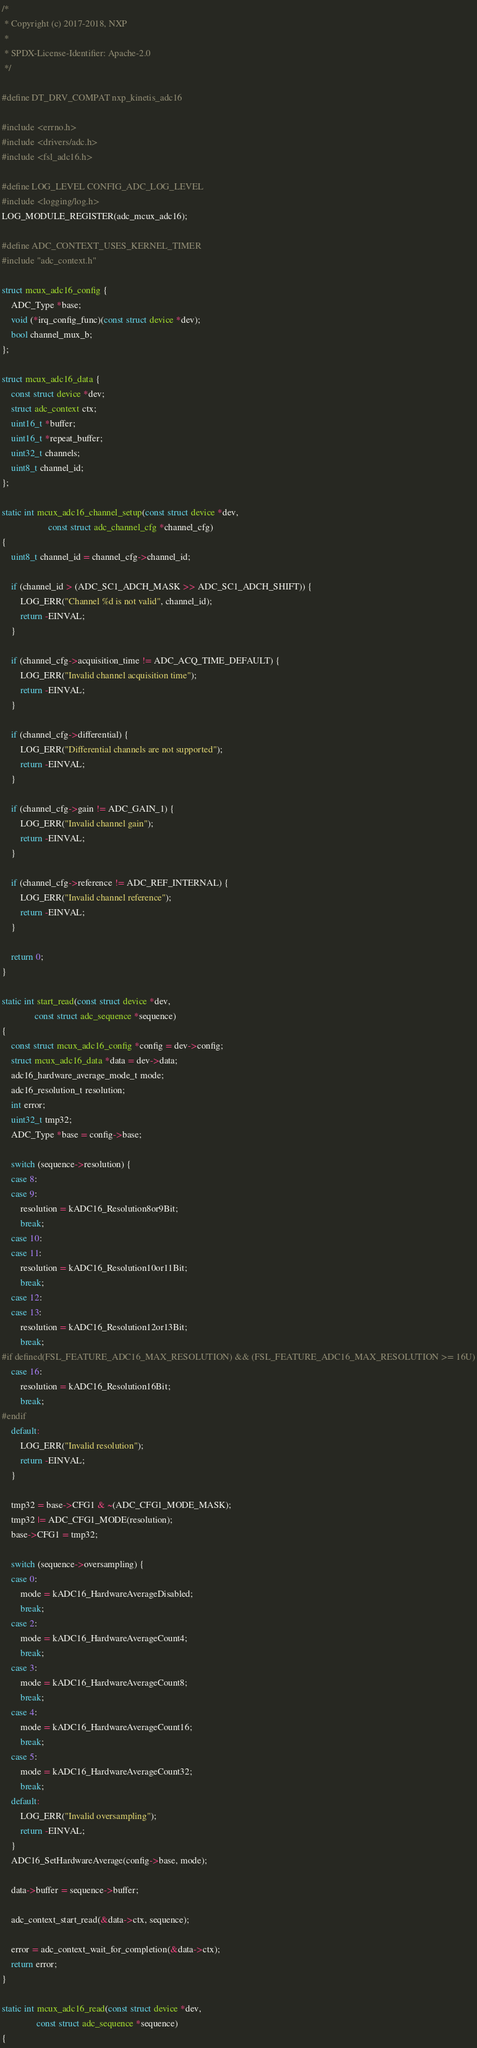Convert code to text. <code><loc_0><loc_0><loc_500><loc_500><_C_>/*
 * Copyright (c) 2017-2018, NXP
 *
 * SPDX-License-Identifier: Apache-2.0
 */

#define DT_DRV_COMPAT nxp_kinetis_adc16

#include <errno.h>
#include <drivers/adc.h>
#include <fsl_adc16.h>

#define LOG_LEVEL CONFIG_ADC_LOG_LEVEL
#include <logging/log.h>
LOG_MODULE_REGISTER(adc_mcux_adc16);

#define ADC_CONTEXT_USES_KERNEL_TIMER
#include "adc_context.h"

struct mcux_adc16_config {
	ADC_Type *base;
	void (*irq_config_func)(const struct device *dev);
	bool channel_mux_b;
};

struct mcux_adc16_data {
	const struct device *dev;
	struct adc_context ctx;
	uint16_t *buffer;
	uint16_t *repeat_buffer;
	uint32_t channels;
	uint8_t channel_id;
};

static int mcux_adc16_channel_setup(const struct device *dev,
				    const struct adc_channel_cfg *channel_cfg)
{
	uint8_t channel_id = channel_cfg->channel_id;

	if (channel_id > (ADC_SC1_ADCH_MASK >> ADC_SC1_ADCH_SHIFT)) {
		LOG_ERR("Channel %d is not valid", channel_id);
		return -EINVAL;
	}

	if (channel_cfg->acquisition_time != ADC_ACQ_TIME_DEFAULT) {
		LOG_ERR("Invalid channel acquisition time");
		return -EINVAL;
	}

	if (channel_cfg->differential) {
		LOG_ERR("Differential channels are not supported");
		return -EINVAL;
	}

	if (channel_cfg->gain != ADC_GAIN_1) {
		LOG_ERR("Invalid channel gain");
		return -EINVAL;
	}

	if (channel_cfg->reference != ADC_REF_INTERNAL) {
		LOG_ERR("Invalid channel reference");
		return -EINVAL;
	}

	return 0;
}

static int start_read(const struct device *dev,
		      const struct adc_sequence *sequence)
{
	const struct mcux_adc16_config *config = dev->config;
	struct mcux_adc16_data *data = dev->data;
	adc16_hardware_average_mode_t mode;
	adc16_resolution_t resolution;
	int error;
	uint32_t tmp32;
	ADC_Type *base = config->base;

	switch (sequence->resolution) {
	case 8:
	case 9:
		resolution = kADC16_Resolution8or9Bit;
		break;
	case 10:
	case 11:
		resolution = kADC16_Resolution10or11Bit;
		break;
	case 12:
	case 13:
		resolution = kADC16_Resolution12or13Bit;
		break;
#if defined(FSL_FEATURE_ADC16_MAX_RESOLUTION) && (FSL_FEATURE_ADC16_MAX_RESOLUTION >= 16U)
	case 16:
		resolution = kADC16_Resolution16Bit;
		break;
#endif
	default:
		LOG_ERR("Invalid resolution");
		return -EINVAL;
	}

	tmp32 = base->CFG1 & ~(ADC_CFG1_MODE_MASK);
	tmp32 |= ADC_CFG1_MODE(resolution);
	base->CFG1 = tmp32;

	switch (sequence->oversampling) {
	case 0:
		mode = kADC16_HardwareAverageDisabled;
		break;
	case 2:
		mode = kADC16_HardwareAverageCount4;
		break;
	case 3:
		mode = kADC16_HardwareAverageCount8;
		break;
	case 4:
		mode = kADC16_HardwareAverageCount16;
		break;
	case 5:
		mode = kADC16_HardwareAverageCount32;
		break;
	default:
		LOG_ERR("Invalid oversampling");
		return -EINVAL;
	}
	ADC16_SetHardwareAverage(config->base, mode);

	data->buffer = sequence->buffer;

	adc_context_start_read(&data->ctx, sequence);

	error = adc_context_wait_for_completion(&data->ctx);
	return error;
}

static int mcux_adc16_read(const struct device *dev,
			   const struct adc_sequence *sequence)
{</code> 